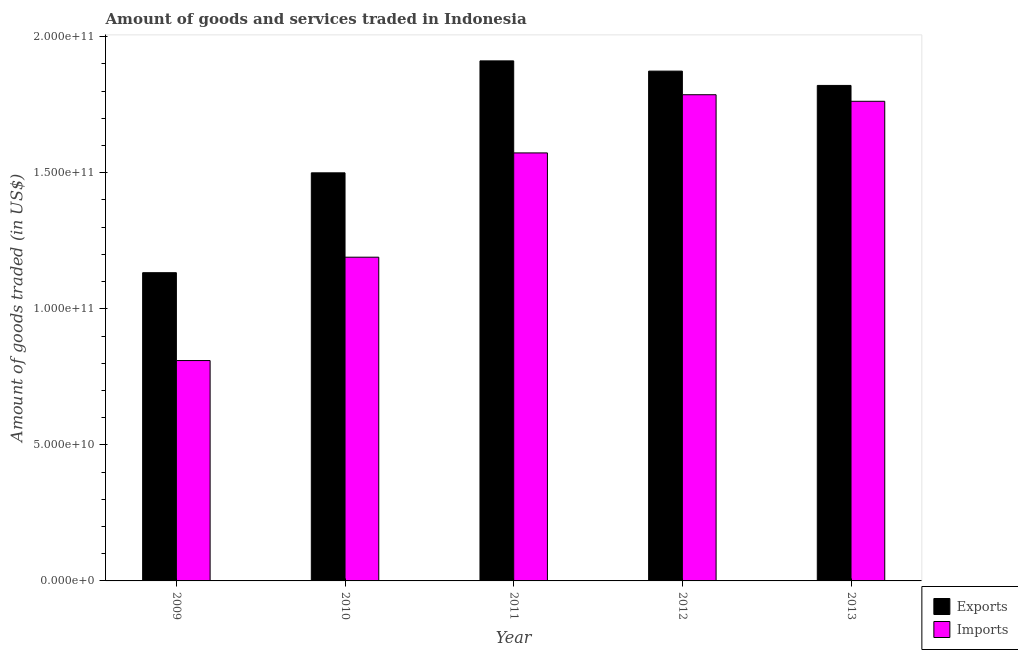How many different coloured bars are there?
Make the answer very short. 2. How many groups of bars are there?
Offer a very short reply. 5. Are the number of bars per tick equal to the number of legend labels?
Ensure brevity in your answer.  Yes. Are the number of bars on each tick of the X-axis equal?
Give a very brief answer. Yes. How many bars are there on the 1st tick from the left?
Keep it short and to the point. 2. How many bars are there on the 2nd tick from the right?
Offer a terse response. 2. What is the label of the 3rd group of bars from the left?
Offer a very short reply. 2011. In how many cases, is the number of bars for a given year not equal to the number of legend labels?
Provide a short and direct response. 0. What is the amount of goods imported in 2009?
Offer a very short reply. 8.10e+1. Across all years, what is the maximum amount of goods exported?
Offer a terse response. 1.91e+11. Across all years, what is the minimum amount of goods exported?
Make the answer very short. 1.13e+11. In which year was the amount of goods imported maximum?
Provide a succinct answer. 2012. What is the total amount of goods exported in the graph?
Offer a very short reply. 8.24e+11. What is the difference between the amount of goods exported in 2009 and that in 2010?
Your response must be concise. -3.67e+1. What is the difference between the amount of goods exported in 2011 and the amount of goods imported in 2010?
Keep it short and to the point. 4.11e+1. What is the average amount of goods exported per year?
Ensure brevity in your answer.  1.65e+11. What is the ratio of the amount of goods exported in 2010 to that in 2011?
Provide a succinct answer. 0.78. What is the difference between the highest and the second highest amount of goods imported?
Your response must be concise. 2.41e+09. What is the difference between the highest and the lowest amount of goods exported?
Keep it short and to the point. 7.78e+1. Is the sum of the amount of goods exported in 2010 and 2013 greater than the maximum amount of goods imported across all years?
Your answer should be compact. Yes. What does the 1st bar from the left in 2013 represents?
Offer a terse response. Exports. What does the 1st bar from the right in 2011 represents?
Your answer should be very brief. Imports. Are all the bars in the graph horizontal?
Your response must be concise. No. How many years are there in the graph?
Your answer should be very brief. 5. Are the values on the major ticks of Y-axis written in scientific E-notation?
Provide a short and direct response. Yes. Does the graph contain grids?
Provide a succinct answer. No. Where does the legend appear in the graph?
Provide a succinct answer. Bottom right. How many legend labels are there?
Provide a short and direct response. 2. How are the legend labels stacked?
Your answer should be compact. Vertical. What is the title of the graph?
Your answer should be compact. Amount of goods and services traded in Indonesia. What is the label or title of the X-axis?
Your answer should be very brief. Year. What is the label or title of the Y-axis?
Make the answer very short. Amount of goods traded (in US$). What is the Amount of goods traded (in US$) of Exports in 2009?
Provide a succinct answer. 1.13e+11. What is the Amount of goods traded (in US$) of Imports in 2009?
Your response must be concise. 8.10e+1. What is the Amount of goods traded (in US$) in Exports in 2010?
Offer a terse response. 1.50e+11. What is the Amount of goods traded (in US$) in Imports in 2010?
Make the answer very short. 1.19e+11. What is the Amount of goods traded (in US$) in Exports in 2011?
Give a very brief answer. 1.91e+11. What is the Amount of goods traded (in US$) in Imports in 2011?
Give a very brief answer. 1.57e+11. What is the Amount of goods traded (in US$) in Exports in 2012?
Make the answer very short. 1.87e+11. What is the Amount of goods traded (in US$) of Imports in 2012?
Provide a succinct answer. 1.79e+11. What is the Amount of goods traded (in US$) of Exports in 2013?
Keep it short and to the point. 1.82e+11. What is the Amount of goods traded (in US$) of Imports in 2013?
Ensure brevity in your answer.  1.76e+11. Across all years, what is the maximum Amount of goods traded (in US$) of Exports?
Make the answer very short. 1.91e+11. Across all years, what is the maximum Amount of goods traded (in US$) of Imports?
Your response must be concise. 1.79e+11. Across all years, what is the minimum Amount of goods traded (in US$) in Exports?
Offer a terse response. 1.13e+11. Across all years, what is the minimum Amount of goods traded (in US$) in Imports?
Your answer should be compact. 8.10e+1. What is the total Amount of goods traded (in US$) in Exports in the graph?
Give a very brief answer. 8.24e+11. What is the total Amount of goods traded (in US$) in Imports in the graph?
Your response must be concise. 7.12e+11. What is the difference between the Amount of goods traded (in US$) of Exports in 2009 and that in 2010?
Make the answer very short. -3.67e+1. What is the difference between the Amount of goods traded (in US$) in Imports in 2009 and that in 2010?
Keep it short and to the point. -3.80e+1. What is the difference between the Amount of goods traded (in US$) of Exports in 2009 and that in 2011?
Provide a short and direct response. -7.78e+1. What is the difference between the Amount of goods traded (in US$) of Imports in 2009 and that in 2011?
Give a very brief answer. -7.63e+1. What is the difference between the Amount of goods traded (in US$) in Exports in 2009 and that in 2012?
Give a very brief answer. -7.41e+1. What is the difference between the Amount of goods traded (in US$) in Imports in 2009 and that in 2012?
Make the answer very short. -9.77e+1. What is the difference between the Amount of goods traded (in US$) of Exports in 2009 and that in 2013?
Give a very brief answer. -6.88e+1. What is the difference between the Amount of goods traded (in US$) of Imports in 2009 and that in 2013?
Provide a short and direct response. -9.53e+1. What is the difference between the Amount of goods traded (in US$) in Exports in 2010 and that in 2011?
Keep it short and to the point. -4.11e+1. What is the difference between the Amount of goods traded (in US$) in Imports in 2010 and that in 2011?
Ensure brevity in your answer.  -3.83e+1. What is the difference between the Amount of goods traded (in US$) in Exports in 2010 and that in 2012?
Provide a short and direct response. -3.74e+1. What is the difference between the Amount of goods traded (in US$) of Imports in 2010 and that in 2012?
Your answer should be compact. -5.97e+1. What is the difference between the Amount of goods traded (in US$) of Exports in 2010 and that in 2013?
Your response must be concise. -3.21e+1. What is the difference between the Amount of goods traded (in US$) of Imports in 2010 and that in 2013?
Your answer should be very brief. -5.73e+1. What is the difference between the Amount of goods traded (in US$) in Exports in 2011 and that in 2012?
Offer a very short reply. 3.76e+09. What is the difference between the Amount of goods traded (in US$) in Imports in 2011 and that in 2012?
Keep it short and to the point. -2.14e+1. What is the difference between the Amount of goods traded (in US$) in Exports in 2011 and that in 2013?
Keep it short and to the point. 9.02e+09. What is the difference between the Amount of goods traded (in US$) in Imports in 2011 and that in 2013?
Your answer should be compact. -1.90e+1. What is the difference between the Amount of goods traded (in US$) of Exports in 2012 and that in 2013?
Give a very brief answer. 5.26e+09. What is the difference between the Amount of goods traded (in US$) in Imports in 2012 and that in 2013?
Keep it short and to the point. 2.41e+09. What is the difference between the Amount of goods traded (in US$) in Exports in 2009 and the Amount of goods traded (in US$) in Imports in 2010?
Offer a terse response. -5.70e+09. What is the difference between the Amount of goods traded (in US$) of Exports in 2009 and the Amount of goods traded (in US$) of Imports in 2011?
Offer a very short reply. -4.40e+1. What is the difference between the Amount of goods traded (in US$) in Exports in 2009 and the Amount of goods traded (in US$) in Imports in 2012?
Offer a very short reply. -6.54e+1. What is the difference between the Amount of goods traded (in US$) in Exports in 2009 and the Amount of goods traded (in US$) in Imports in 2013?
Your response must be concise. -6.30e+1. What is the difference between the Amount of goods traded (in US$) in Exports in 2010 and the Amount of goods traded (in US$) in Imports in 2011?
Ensure brevity in your answer.  -7.32e+09. What is the difference between the Amount of goods traded (in US$) in Exports in 2010 and the Amount of goods traded (in US$) in Imports in 2012?
Provide a succinct answer. -2.87e+1. What is the difference between the Amount of goods traded (in US$) in Exports in 2010 and the Amount of goods traded (in US$) in Imports in 2013?
Ensure brevity in your answer.  -2.63e+1. What is the difference between the Amount of goods traded (in US$) in Exports in 2011 and the Amount of goods traded (in US$) in Imports in 2012?
Ensure brevity in your answer.  1.24e+1. What is the difference between the Amount of goods traded (in US$) of Exports in 2011 and the Amount of goods traded (in US$) of Imports in 2013?
Your answer should be compact. 1.49e+1. What is the difference between the Amount of goods traded (in US$) of Exports in 2012 and the Amount of goods traded (in US$) of Imports in 2013?
Your response must be concise. 1.11e+1. What is the average Amount of goods traded (in US$) of Exports per year?
Offer a terse response. 1.65e+11. What is the average Amount of goods traded (in US$) in Imports per year?
Make the answer very short. 1.42e+11. In the year 2009, what is the difference between the Amount of goods traded (in US$) of Exports and Amount of goods traded (in US$) of Imports?
Provide a succinct answer. 3.23e+1. In the year 2010, what is the difference between the Amount of goods traded (in US$) in Exports and Amount of goods traded (in US$) in Imports?
Provide a succinct answer. 3.10e+1. In the year 2011, what is the difference between the Amount of goods traded (in US$) in Exports and Amount of goods traded (in US$) in Imports?
Your answer should be very brief. 3.38e+1. In the year 2012, what is the difference between the Amount of goods traded (in US$) of Exports and Amount of goods traded (in US$) of Imports?
Your answer should be compact. 8.68e+09. In the year 2013, what is the difference between the Amount of goods traded (in US$) of Exports and Amount of goods traded (in US$) of Imports?
Provide a short and direct response. 5.83e+09. What is the ratio of the Amount of goods traded (in US$) of Exports in 2009 to that in 2010?
Your response must be concise. 0.76. What is the ratio of the Amount of goods traded (in US$) in Imports in 2009 to that in 2010?
Your answer should be compact. 0.68. What is the ratio of the Amount of goods traded (in US$) in Exports in 2009 to that in 2011?
Give a very brief answer. 0.59. What is the ratio of the Amount of goods traded (in US$) in Imports in 2009 to that in 2011?
Your response must be concise. 0.51. What is the ratio of the Amount of goods traded (in US$) in Exports in 2009 to that in 2012?
Offer a very short reply. 0.6. What is the ratio of the Amount of goods traded (in US$) in Imports in 2009 to that in 2012?
Keep it short and to the point. 0.45. What is the ratio of the Amount of goods traded (in US$) of Exports in 2009 to that in 2013?
Your response must be concise. 0.62. What is the ratio of the Amount of goods traded (in US$) of Imports in 2009 to that in 2013?
Offer a very short reply. 0.46. What is the ratio of the Amount of goods traded (in US$) in Exports in 2010 to that in 2011?
Provide a succinct answer. 0.78. What is the ratio of the Amount of goods traded (in US$) of Imports in 2010 to that in 2011?
Offer a terse response. 0.76. What is the ratio of the Amount of goods traded (in US$) in Exports in 2010 to that in 2012?
Offer a terse response. 0.8. What is the ratio of the Amount of goods traded (in US$) in Imports in 2010 to that in 2012?
Your response must be concise. 0.67. What is the ratio of the Amount of goods traded (in US$) in Exports in 2010 to that in 2013?
Your response must be concise. 0.82. What is the ratio of the Amount of goods traded (in US$) of Imports in 2010 to that in 2013?
Your answer should be very brief. 0.67. What is the ratio of the Amount of goods traded (in US$) in Exports in 2011 to that in 2012?
Provide a succinct answer. 1.02. What is the ratio of the Amount of goods traded (in US$) of Imports in 2011 to that in 2012?
Ensure brevity in your answer.  0.88. What is the ratio of the Amount of goods traded (in US$) of Exports in 2011 to that in 2013?
Your answer should be very brief. 1.05. What is the ratio of the Amount of goods traded (in US$) in Imports in 2011 to that in 2013?
Your answer should be compact. 0.89. What is the ratio of the Amount of goods traded (in US$) in Exports in 2012 to that in 2013?
Your response must be concise. 1.03. What is the ratio of the Amount of goods traded (in US$) of Imports in 2012 to that in 2013?
Keep it short and to the point. 1.01. What is the difference between the highest and the second highest Amount of goods traded (in US$) of Exports?
Ensure brevity in your answer.  3.76e+09. What is the difference between the highest and the second highest Amount of goods traded (in US$) of Imports?
Your response must be concise. 2.41e+09. What is the difference between the highest and the lowest Amount of goods traded (in US$) in Exports?
Make the answer very short. 7.78e+1. What is the difference between the highest and the lowest Amount of goods traded (in US$) of Imports?
Your response must be concise. 9.77e+1. 